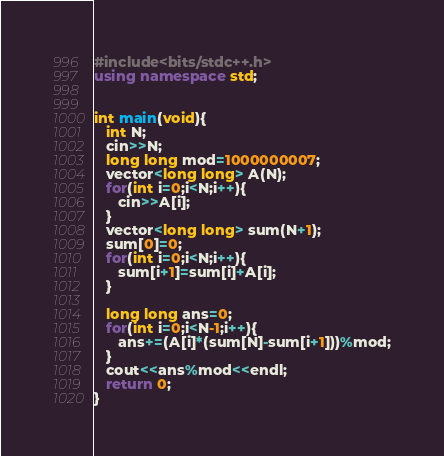<code> <loc_0><loc_0><loc_500><loc_500><_C++_>#include<bits/stdc++.h>
using namespace std;


int main(void){
   int N;
   cin>>N;
   long long mod=1000000007;
   vector<long long> A(N);
   for(int i=0;i<N;i++){
      cin>>A[i];
   }
   vector<long long> sum(N+1);
   sum[0]=0;
   for(int i=0;i<N;i++){
      sum[i+1]=sum[i]+A[i];
   }
   
   long long ans=0;
   for(int i=0;i<N-1;i++){
      ans+=(A[i]*(sum[N]-sum[i+1]))%mod;
   }
   cout<<ans%mod<<endl;
   return 0;
}
</code> 